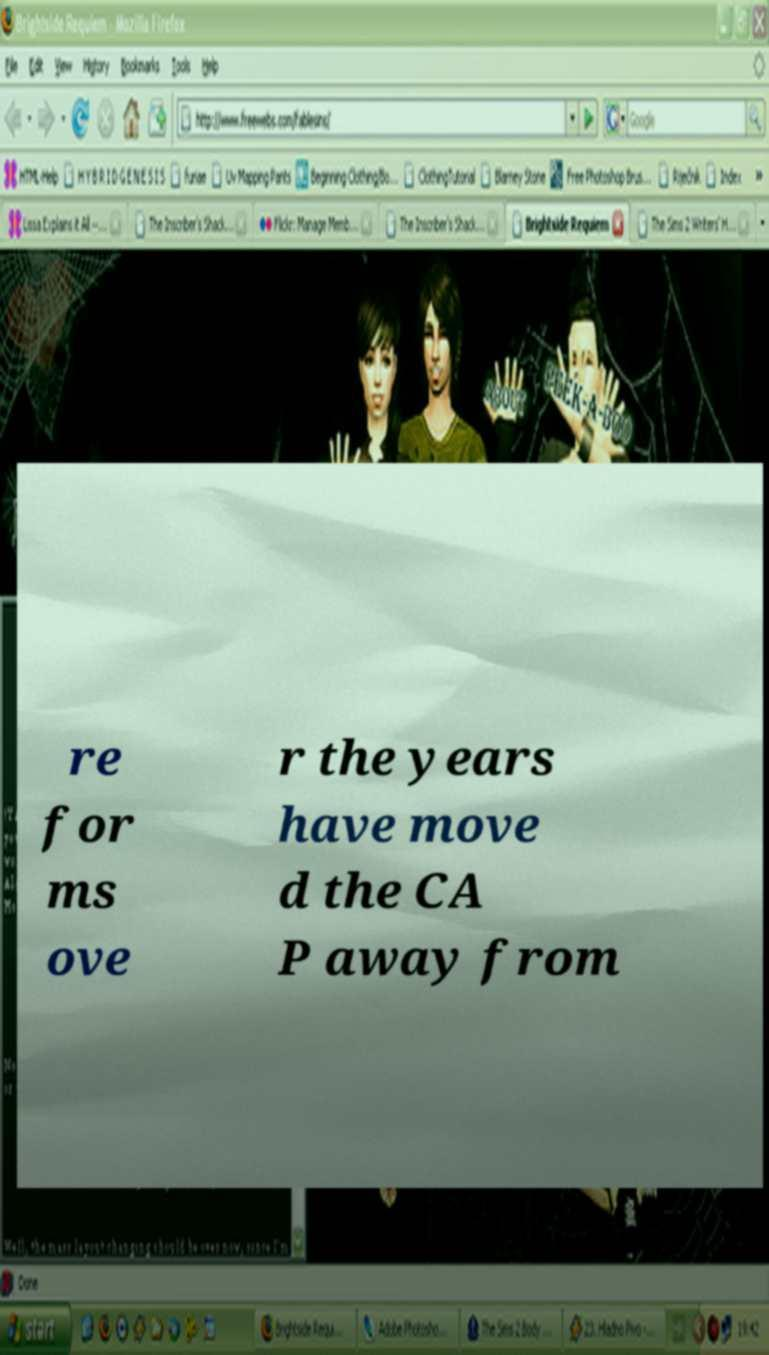Please identify and transcribe the text found in this image. re for ms ove r the years have move d the CA P away from 